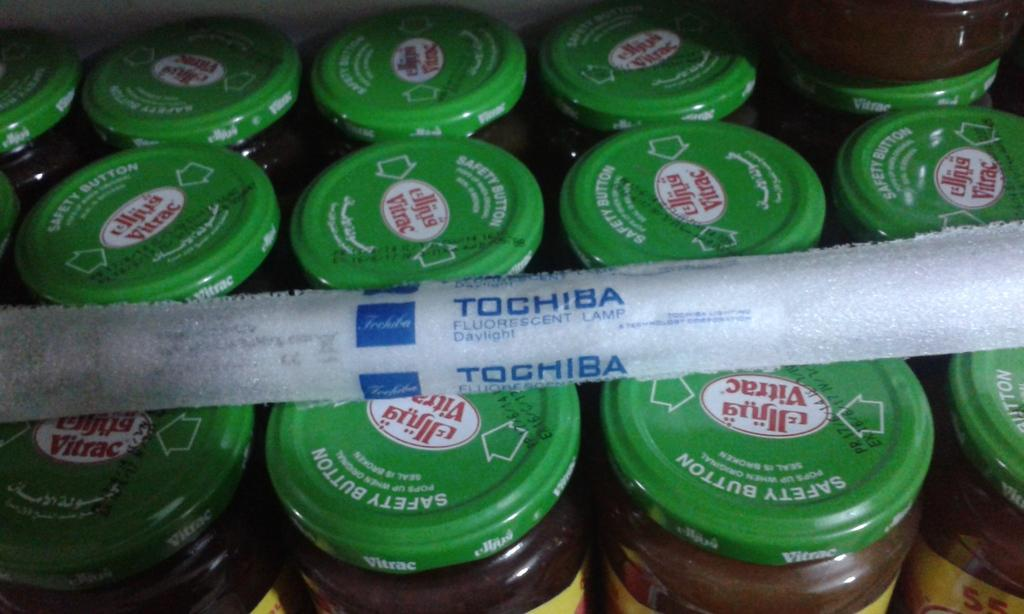What type of containers are visible in the image? There are glass jars in the image. How are the glass jars sealed or closed? The glass jars have caps on them. Where are the glass jars located in the image? The glass jars are placed on a surface. What is covering the top of the glass jars? There is a cloth present at the top of the jars. What type of insurance policy is mentioned in the image? There is no mention of any insurance policy in the image. 